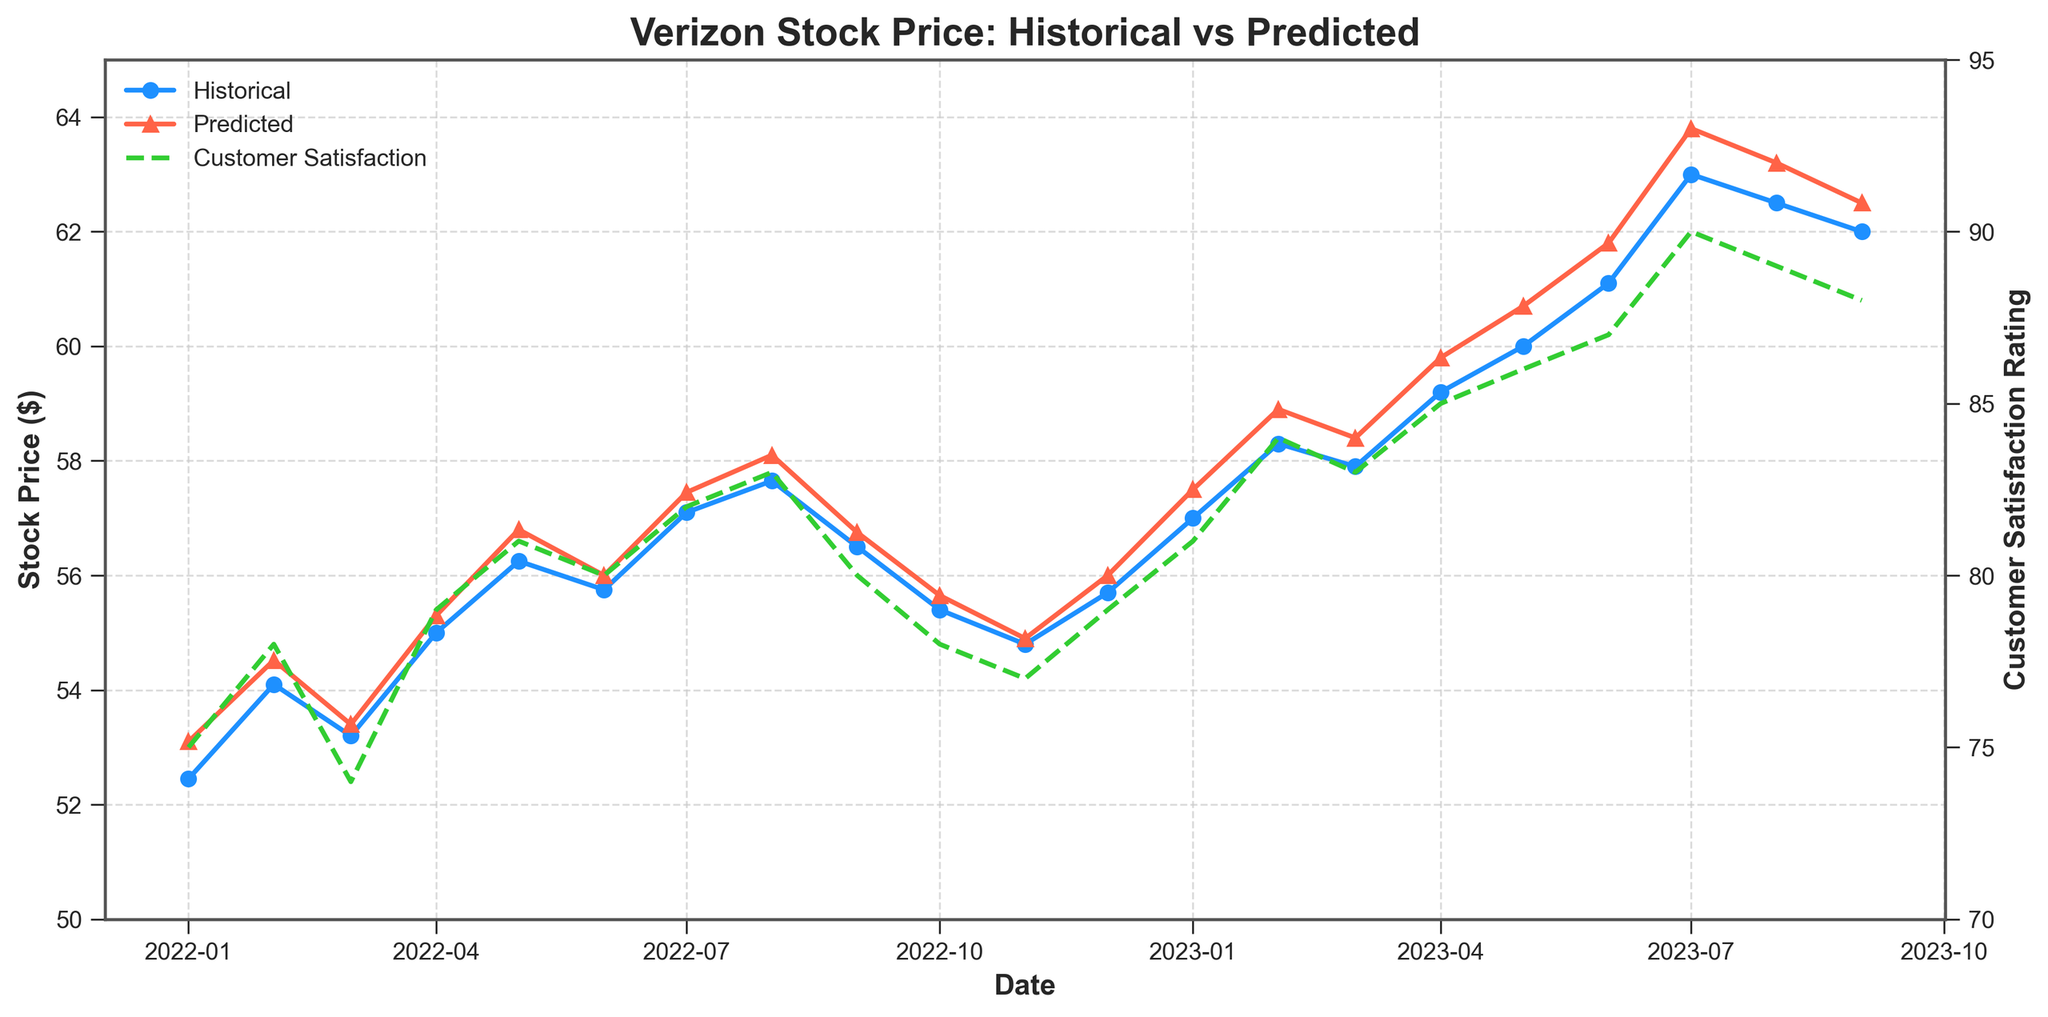What's the title of the plot? The title is located at the top center of the figure. It helps in quickly understanding the subject of the visual representation.
Answer: Verizon Stock Price: Historical vs Predicted What are the two lines plotted on the primary y-axis representing? The primary y-axis on the left side of the figure has two lines. The blue line with circle markers represents the Historical stock prices, and the red line with triangle markers represents the Predicted stock prices.
Answer: Historical stock prices and Predicted stock prices How is the customer satisfaction rating represented in the plot? The customer satisfaction rating is represented by the green dashed line, which runs through the chart using the secondary y-axis on the right side. This secondary axis helps distinguish and align customer satisfaction ratings with the date.
Answer: A green dashed line What is the range of the stock prices plotted on the y-axis? The primary y-axis on the left side, representing stock prices, ranges from 50 to 65 dollars. This can be observed by looking at the axis labels.
Answer: 50 to 65 dollars How does the stock price change from January 2023 to February 2023? The historical stock price in January 2023 is $57.00 and increases to $58.30 in February 2023. This change can be observed from the blue line with circle markers.
Answer: Increases by $1.30 What is the highest predicted stock price in the plot, and when does it occur? The highest predicted stock price is $63.80, which occurs in July 2023. This can be found by following the red line with triangle markers.
Answer: $63.80 in July 2023 Is there a trend between customer satisfaction ratings and stock prices? Both customer satisfaction ratings and stock prices generally show an upward trend over time. As customer satisfaction increases, stock prices (both historical and predicted) also tend to rise. This trend is evident when comparing the green dashed line with the blue and red lines.
Answer: Yes, a positive trend What is the difference between the highest and lowest customer satisfaction ratings? The highest customer satisfaction rating is 90 (July 2023), and the lowest is 74 (March 2022). The difference is calculated by subtracting the lowest rating from the highest.
Answer: 16 How did the predicted stock price in January 2023 compare to the actual historical stock price? The predicted stock price in January 2023 was $57.50, while the historical stock price was $57.00. The difference between the two is $0.50.
Answer: Higher by $0.50 What's the average historical stock price for the first half of 2022? To calculate, sum the historical stock prices from January to June 2022 (52.45 + 54.10 + 53.20 + 55.00 + 56.25 + 55.75), then divide by the number of values (6). The result is the average.
Answer: $54.46 